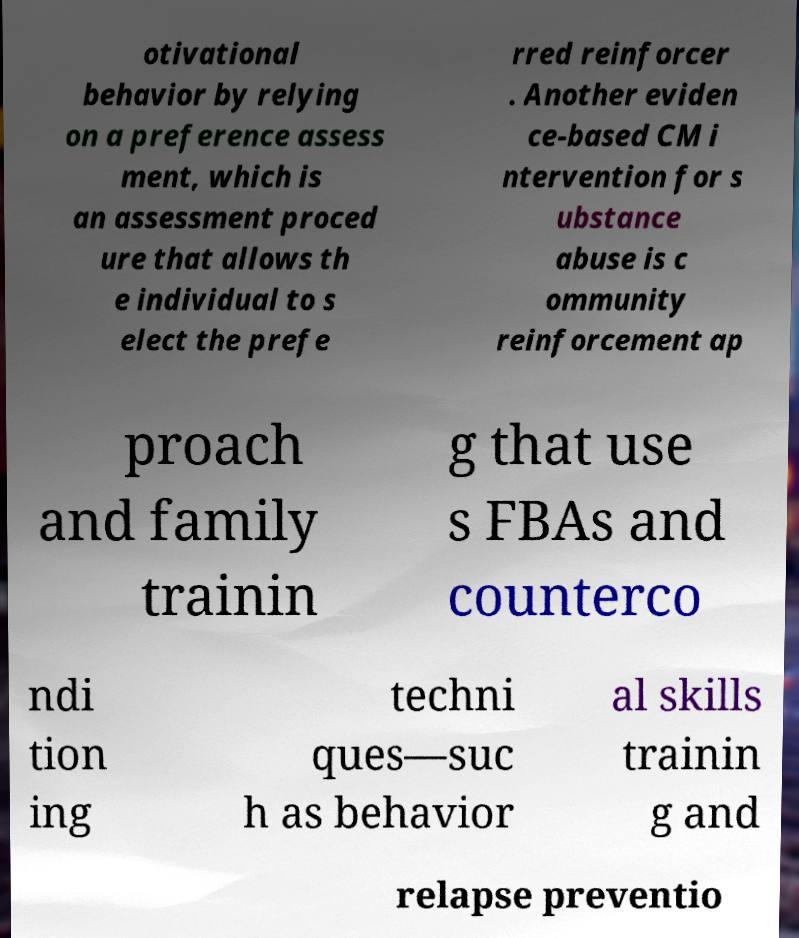For documentation purposes, I need the text within this image transcribed. Could you provide that? otivational behavior by relying on a preference assess ment, which is an assessment proced ure that allows th e individual to s elect the prefe rred reinforcer . Another eviden ce-based CM i ntervention for s ubstance abuse is c ommunity reinforcement ap proach and family trainin g that use s FBAs and counterco ndi tion ing techni ques—suc h as behavior al skills trainin g and relapse preventio 